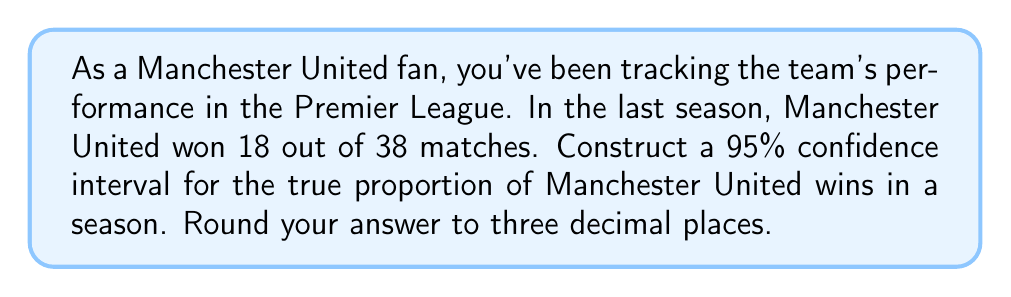Could you help me with this problem? Let's approach this step-by-step:

1) First, we need to identify our variables:
   $n$ = number of matches = 38
   $X$ = number of wins = 18
   $\hat{p}$ = sample proportion = $X/n$ = 18/38 = 0.4737

2) For a 95% confidence interval, we use $z_{0.025} = 1.96$

3) The formula for the confidence interval is:

   $$\hat{p} \pm z_{0.025} \sqrt{\frac{\hat{p}(1-\hat{p})}{n}}$$

4) Let's calculate the margin of error:

   $$\text{ME} = 1.96 \sqrt{\frac{0.4737(1-0.4737)}{38}}$$
   $$= 1.96 \sqrt{\frac{0.4737 \times 0.5263}{38}}$$
   $$= 1.96 \sqrt{0.006558}$$
   $$= 1.96 \times 0.08099$$
   $$= 0.1587$$

5) Now we can construct the confidence interval:

   Lower bound: $0.4737 - 0.1587 = 0.3150$
   Upper bound: $0.4737 + 0.1587 = 0.6324$

6) Rounding to three decimal places:

   (0.315, 0.632)

Therefore, we can be 95% confident that the true proportion of Manchester United wins in a season falls between 0.315 and 0.632.
Answer: (0.315, 0.632) 